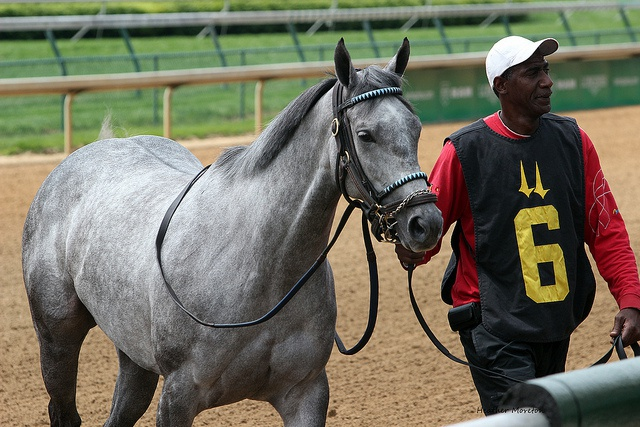Describe the objects in this image and their specific colors. I can see horse in darkgray, gray, black, and lightgray tones, people in darkgray, black, maroon, brown, and olive tones, and cell phone in darkgray, black, gray, and darkblue tones in this image. 